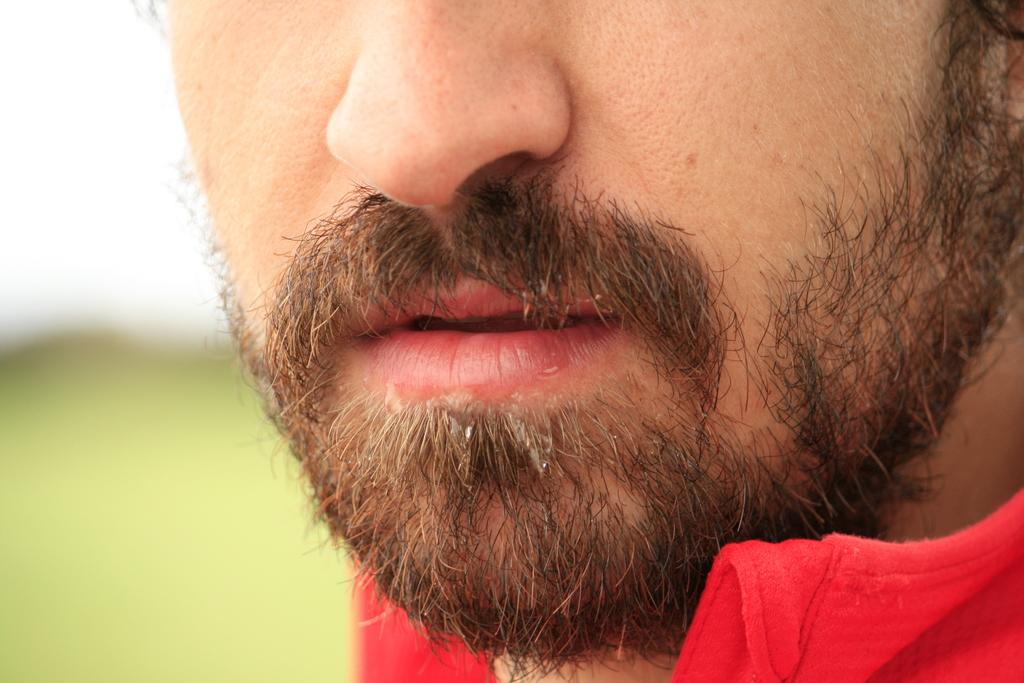Who is the main subject in the image? There is a man in the image. What can be observed about the background of the image? The background of the image is blurred. What type of addition problem is the man solving in the image? There is no addition problem or any indication of mathematical activity in the image. 